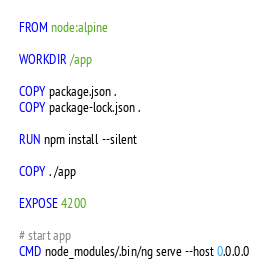<code> <loc_0><loc_0><loc_500><loc_500><_Dockerfile_>FROM node:alpine

WORKDIR /app

COPY package.json .
COPY package-lock.json .

RUN npm install --silent

COPY . /app

EXPOSE 4200

# start app
CMD node_modules/.bin/ng serve --host 0.0.0.0

</code> 